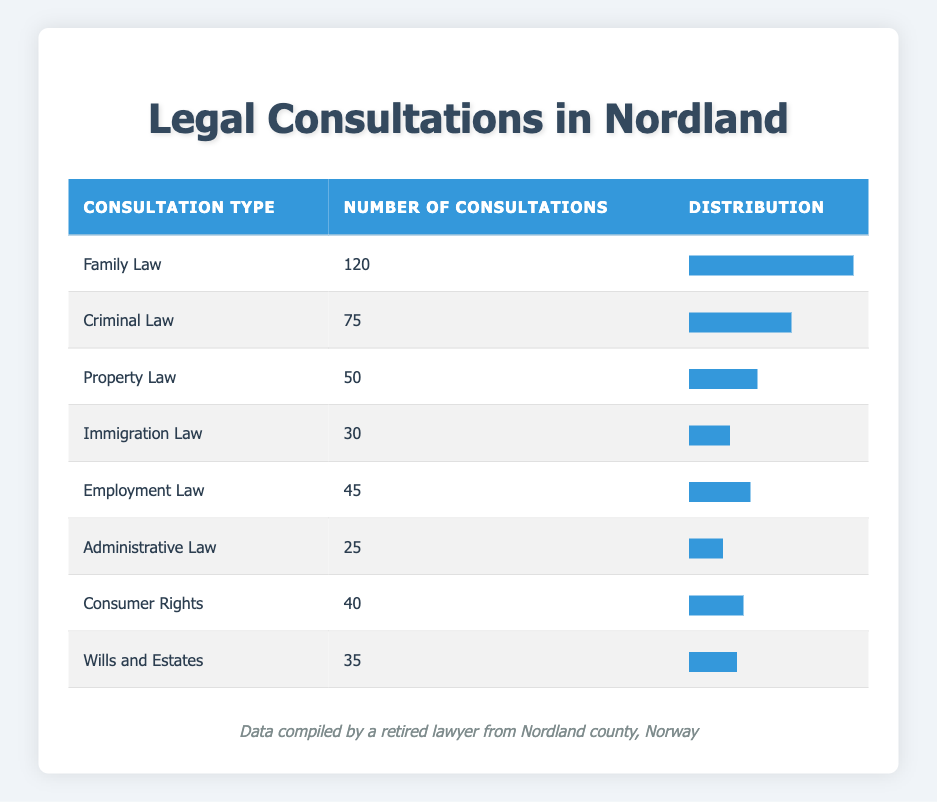What is the total number of legal consultations across all types? To find the total number of legal consultations, we need to add up the number of consultations for each consultation type. This is calculated as follows: 120 (Family Law) + 75 (Criminal Law) + 50 (Property Law) + 30 (Immigration Law) + 45 (Employment Law) + 25 (Administrative Law) + 40 (Consumer Rights) + 35 (Wills and Estates) = 420.
Answer: 420 Which type of legal consultation had the least number of consultations? By examining the 'Number of Consultations' column, we can identify that 'Administrative Law' has the least at 25 consultations.
Answer: Administrative Law Is the number of Family Law consultations greater than the number of Employment Law consultations? We compare the values: Family Law has 120 consultations, while Employment Law has 45 consultations. Since 120 is greater than 45, the statement is true.
Answer: Yes How many more consultations were there for Criminal Law compared to Immigration Law? We find the difference between Criminal Law and Immigration Law consultations: 75 (Criminal Law) - 30 (Immigration Law) = 45. Therefore, there were 45 more consultations for Criminal Law than Immigration Law.
Answer: 45 What percentage of the total consultations were for Property Law? First, we determine the total number of consultations, which is 420. Next, we calculate the percentage for Property Law by using the formula: (Number of Property Law Consultations / Total Consultations) * 100 = (50 / 420) * 100 = 11.90%.
Answer: 11.90% Which two consultation types had the highest number of consultations combined? We identify the two highest consultation types from the table, which are Family Law (120) and Criminal Law (75). We then sum these values: 120 + 75 = 195. Therefore, the two types with the highest consultations combined is 195.
Answer: 195 Is the number of consultations for Consumer Rights greater than for Wills and Estates? Comparing the values: Consumer Rights has 40 consultations and Wills and Estates has 35 consultations. Since 40 is greater than 35, the answer is yes.
Answer: Yes What is the median number of consultations among all types? To find the median, we first list the number of consultations in ascending order: 25, 30, 35, 40, 45, 50, 75, 120. With 8 consultation types, the median is the average of the 4th and 5th values: (40 + 45) / 2 = 42.5. Therefore, the median number of consultations is 42.5.
Answer: 42.5 